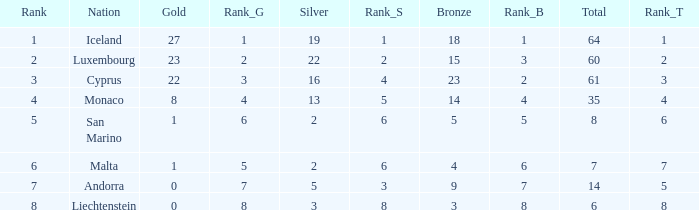How many bronzes for Iceland with over 2 silvers? 18.0. 